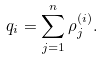Convert formula to latex. <formula><loc_0><loc_0><loc_500><loc_500>q _ { i } = \sum _ { j = 1 } ^ { n } \rho _ { j } ^ { ( i ) } .</formula> 